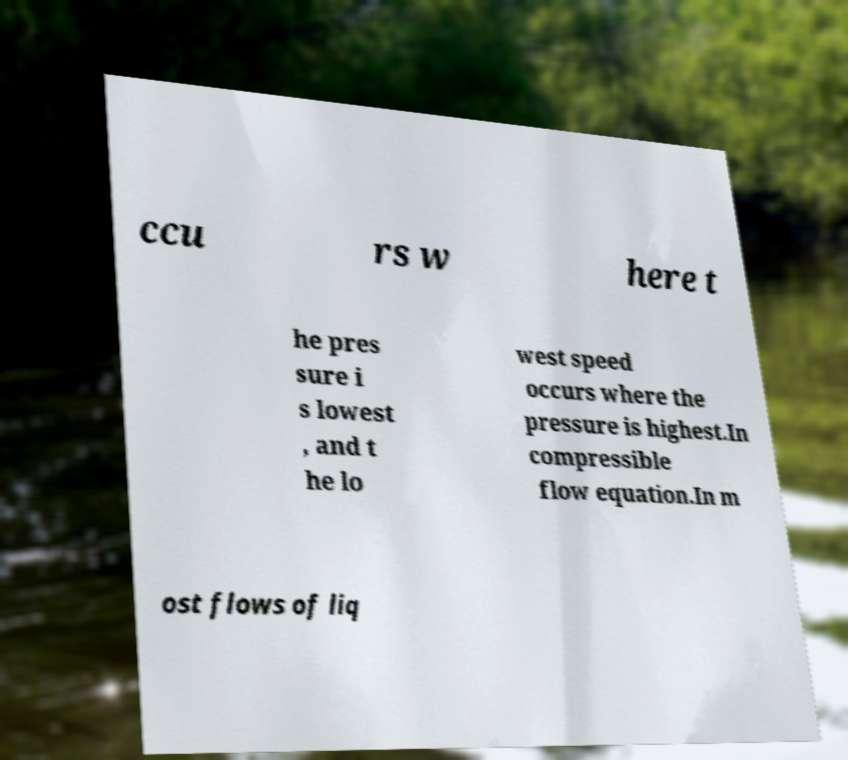Could you assist in decoding the text presented in this image and type it out clearly? ccu rs w here t he pres sure i s lowest , and t he lo west speed occurs where the pressure is highest.In compressible flow equation.In m ost flows of liq 